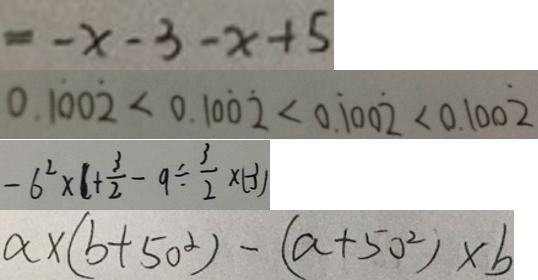<formula> <loc_0><loc_0><loc_500><loc_500>= - x - 3 - x + 5 
 0 . 1 \dot { 0 } 0 \dot { 2 } < 0 . 1 0 \dot { 0 } \dot { 2 } < 0 . \dot { 1 } 0 0 \dot { 2 } < 0 . 1 0 0 \dot { 2 } 
 - 6 ^ { 2 } \times 1 + \frac { 3 } { 2 } - 9 \div \frac { 3 } { 2 } \times ( - 3 ) 
 a \times ( b + 5 0 ^ { 2 } ) - ( a + 5 0 ^ { 2 } ) \times b</formula> 